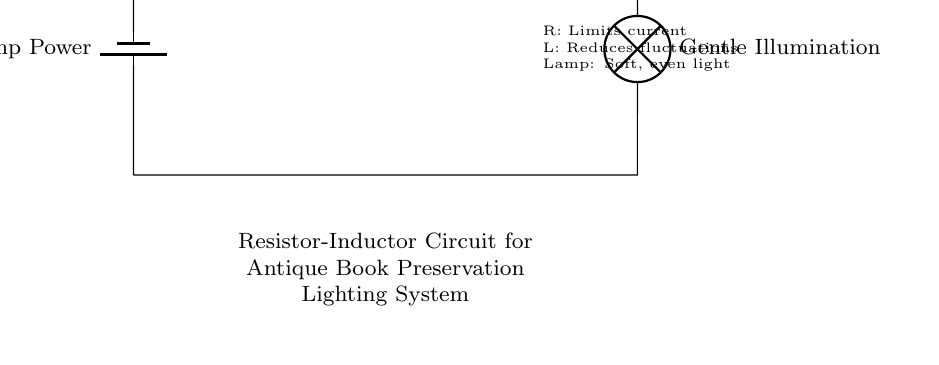What components are present in the circuit? The circuit diagram includes a battery, a resistor, an inductor, and a lamp, which are all indicated by their respective symbols.
Answer: battery, resistor, inductor, lamp What is the purpose of the resistor in this circuit? The resistor's role is to limit the current passing through the circuit, which helps to prevent damage to the other components, especially the lamp.
Answer: limit current How does the inductor function in this lighting system? The inductor acts as an inductive filter, which reduces fluctuations in the electrical current, ensuring that the lamp receives a steady and smooth flow of electricity.
Answer: reduces fluctuations What type of light does the lamp produce? The lamp is designed to provide a gentle illumination, which is ideal for preserving antique books and minimizing damage.
Answer: gentle illumination What is the overall function of this circuit? This Resistor-Inductor circuit is specifically designed to serve as a lighting system for antique book preservation, providing stable and soft illumination to avoid harming the books.
Answer: antique book preservation lighting How does the combination of the resistor and inductor improve lighting for antiques? Together, the resistor limits excess current while the inductor smooths out the current flow, decreasing the risk of bright flashes or sudden surges that could harm delicate materials.
Answer: protects antiques What does the circuit say about current management? The presence of both a resistor and an inductor highlights a dual approach to managing current: limiting it and filtering for stability, which is crucial for delicate systems.
Answer: current management 